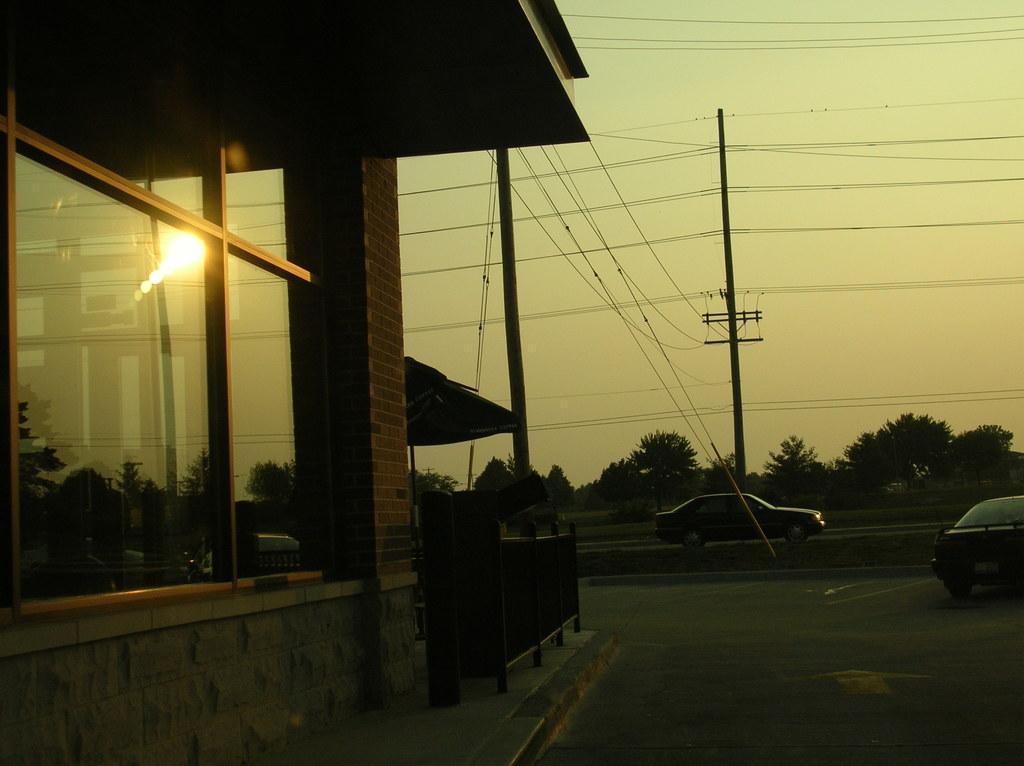What can be seen on the road in the image? There are cars on the road in the image. What type of structure is present in the image? There is a building in the image. What objects are present in the image that are used for support or attachment? There are poles and wires in the image. What type of barrier is present in the image? There is a fence in the image. What is visible in the background of the image? There are trees and the sky in the background of the image. Can you tell me what type of flower is being written about on the sheet in the image? There is no flower, writer, or sheet present in the image. 